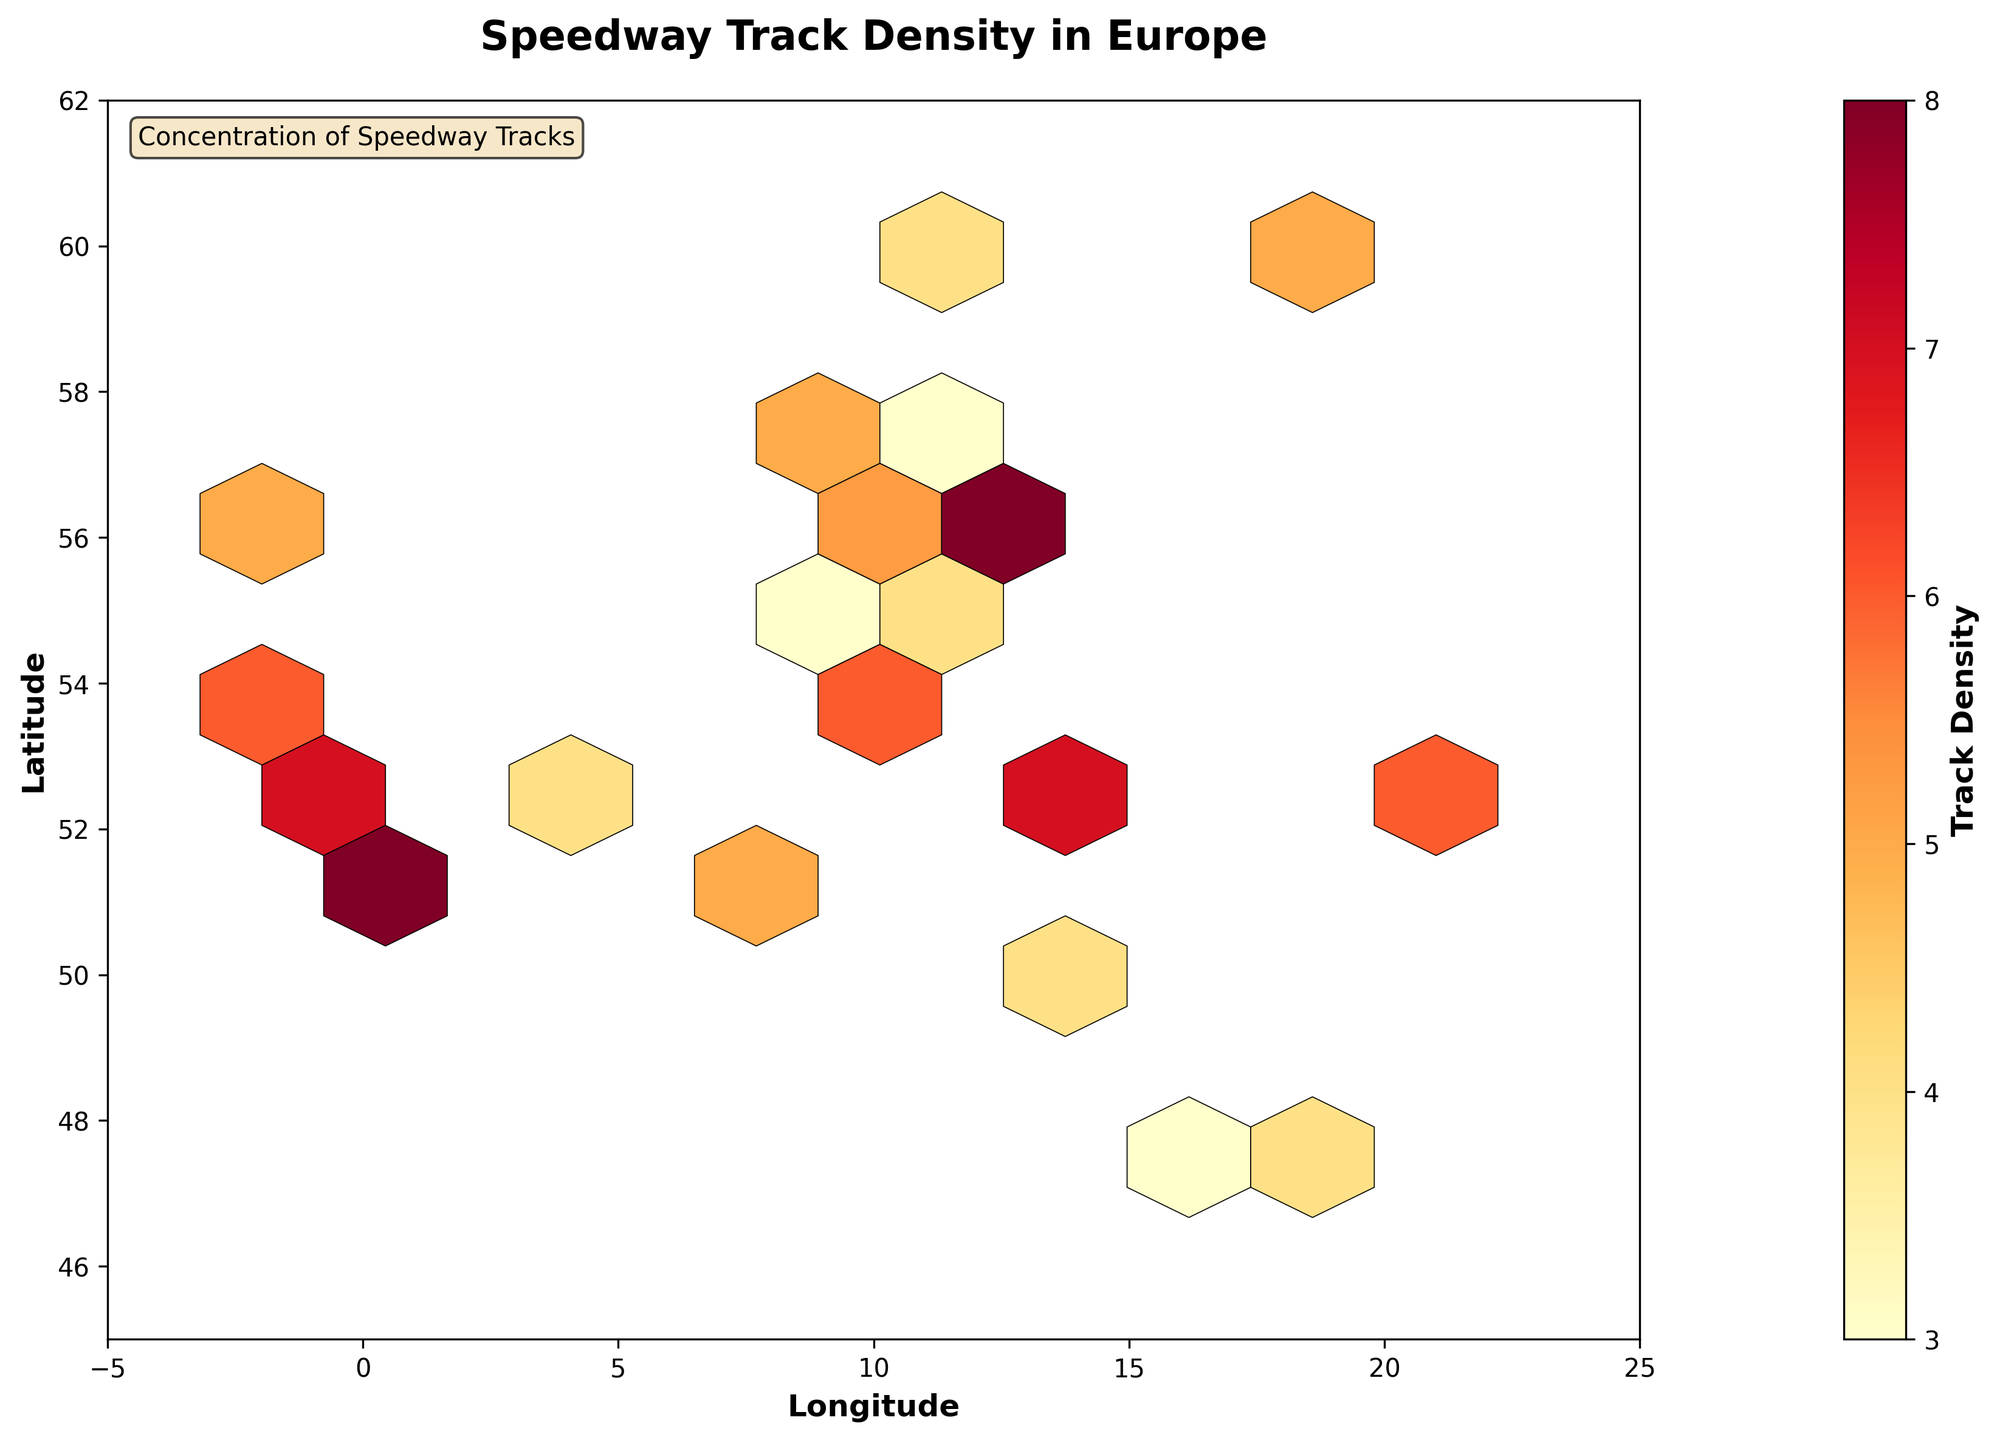What is the title of the figure? The title is located at the top of the figure in a larger and bold font reading "Speedway Track Density in Europe".
Answer: Speedway Track Density in Europe What does the color bar on the right of the figure represent? The color bar shows the 'Track Density' label, indicating it represents the density of speedway tracks, with different colors corresponding to different density values.
Answer: Track Density Which parts of Europe have the highest concentration of speedway tracks based on the hexbin colors? By observing the hexbin colors, the darker reds indicate higher concentrations. Areas around Denmark (central northern Europe) and parts of Germany and the UK have the highest density.
Answer: Denmark, parts of Germany, and the UK What is the range of 'Longitude' and 'Latitude' displayed on the axes? The x-axis (Longitude) ranges from -5 to 25, and the y-axis (Latitude) ranges from 45 to 62, as specified by the axis labels and tick marks.
Answer: Longitude: -5 to 25, Latitude: 45 to 62 How does the track density vary between countries in Scandinavia and Eastern Europe? By comparing hexbin colors, Scandinavia (e.g., Norway, Sweden) has moderate yellow/orange indicating medium density, while Eastern Europe (e.g., Poland, Hungary) shows fewer or lighter-colored hexagons indicating lower density.
Answer: Scandinavia has medium density; Eastern Europe has lower density What indicates a higher density of speedway tracks in the hexbin plot? Higher densities are represented by darker red hexagons, while lower densities are shown by lighter colors such as yellow.
Answer: Darker red hexagons Is the track density higher in Berlin or Vienna? By comparing hexbin colors, Berlin (approximately 13 longitude, 52 latitude) has a darker color hexagon than Vienna (approximately 16 longitude, 48 latitude), indicating higher density in Berlin.
Answer: Berlin What does the annotation at the top-left of the plot indicate? The annotation states "Concentration of Speedway Tracks" to highlight the plot is showing density/clustering of speedway tracks.
Answer: Concentration of Speedway Tracks Where would you expect to find the hexagons with the lowest density? The lightest-colored hexagons, which signify the lowest density, seem to be found at the edges of the plotted area, such as parts of Eastern Europe and southwestern edges.
Answer: Edges of the plotted area (Eastern Europe and southwestern edges) Which has a higher track density, the area around London or the area around Copenhagen? Based on the hexbin colors, the area around London (51.5 latitude, -0.1 longitude) has a darker hexbin than Copenhagen (55.7 latitude, 12.6 longitude), indicating a higher track density in London.
Answer: London 